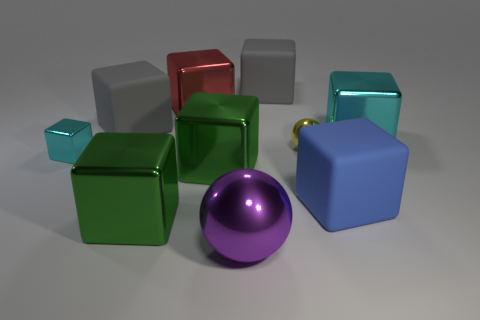Are there an equal number of shiny objects that are in front of the purple shiny sphere and brown shiny cubes?
Make the answer very short. Yes. What material is the big object that is the same color as the small cube?
Your answer should be compact. Metal. Do the blue matte thing and the cyan cube on the right side of the large purple metallic sphere have the same size?
Make the answer very short. Yes. How many other objects are the same size as the purple thing?
Your answer should be compact. 7. What number of other objects are there of the same color as the tiny metallic cube?
Provide a succinct answer. 1. What number of other objects are there of the same shape as the large red metallic thing?
Offer a very short reply. 7. Do the yellow object and the purple shiny thing have the same size?
Your response must be concise. No. Are any tiny yellow shiny cylinders visible?
Give a very brief answer. No. Is there a green thing made of the same material as the small cyan block?
Provide a short and direct response. Yes. There is a blue cube that is the same size as the purple thing; what material is it?
Your answer should be compact. Rubber. 